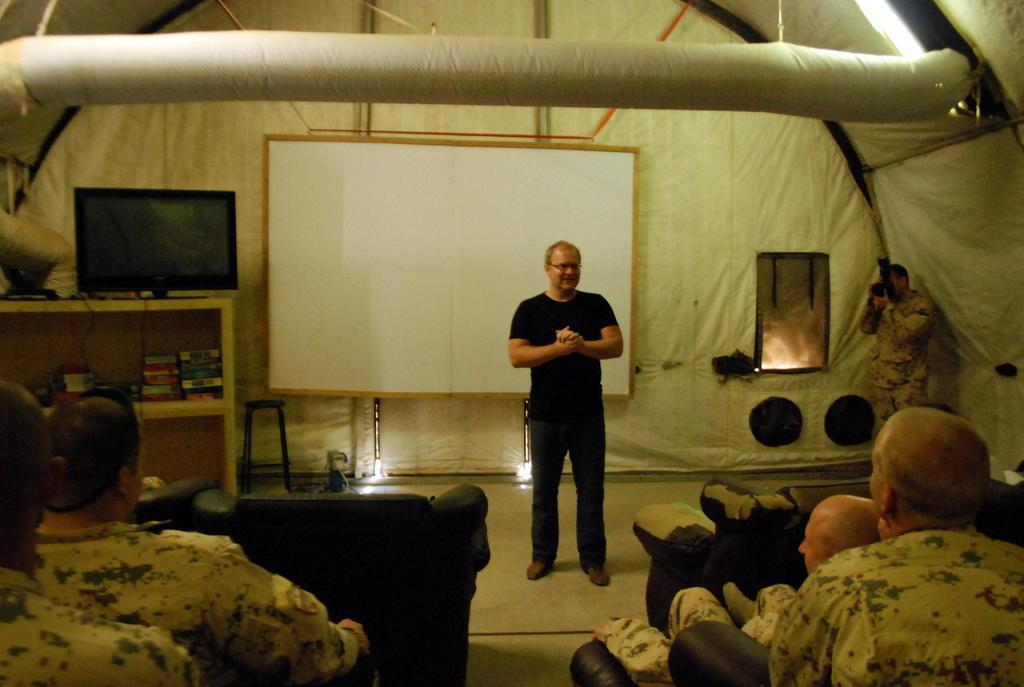How would you summarize this image in a sentence or two? In this image there is a TV on the table, under that there are books in the shelf, beside the table there is a white board on the wall also there is a man in black costume standing in the middle and speaking in front of him there are so many other people sitting in the chairs also there is other man standing at the left corner holding a camera under the tent. 